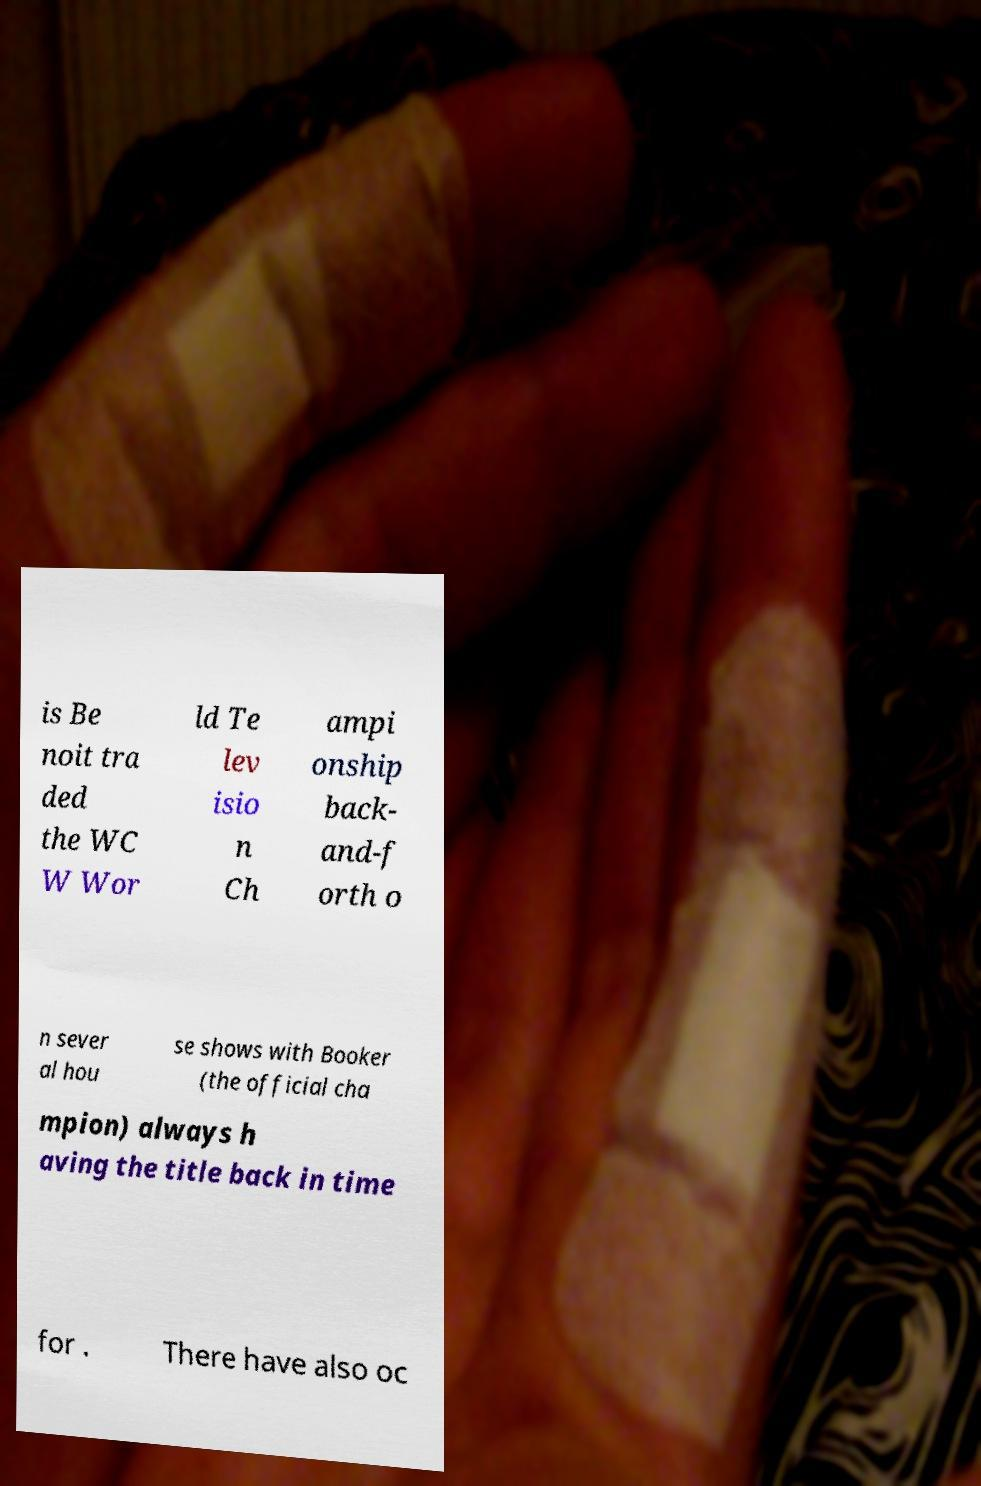What messages or text are displayed in this image? I need them in a readable, typed format. is Be noit tra ded the WC W Wor ld Te lev isio n Ch ampi onship back- and-f orth o n sever al hou se shows with Booker (the official cha mpion) always h aving the title back in time for . There have also oc 